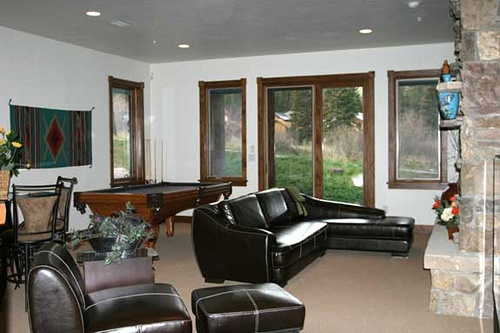Describe the objects in this image and their specific colors. I can see couch in gray, black, white, and darkgray tones, chair in gray and black tones, couch in gray and black tones, potted plant in gray, black, darkgray, and maroon tones, and chair in gray and black tones in this image. 